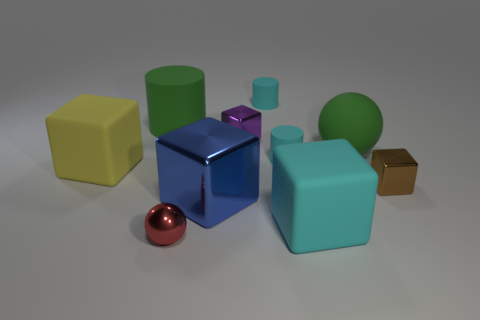Subtract all yellow cubes. How many cubes are left? 4 Subtract all big metal blocks. How many blocks are left? 4 Subtract all brown blocks. Subtract all brown balls. How many blocks are left? 4 Subtract all spheres. How many objects are left? 8 Subtract all tiny yellow rubber things. Subtract all tiny rubber cylinders. How many objects are left? 8 Add 7 brown metal cubes. How many brown metal cubes are left? 8 Add 2 small brown metal objects. How many small brown metal objects exist? 3 Subtract 1 green cylinders. How many objects are left? 9 